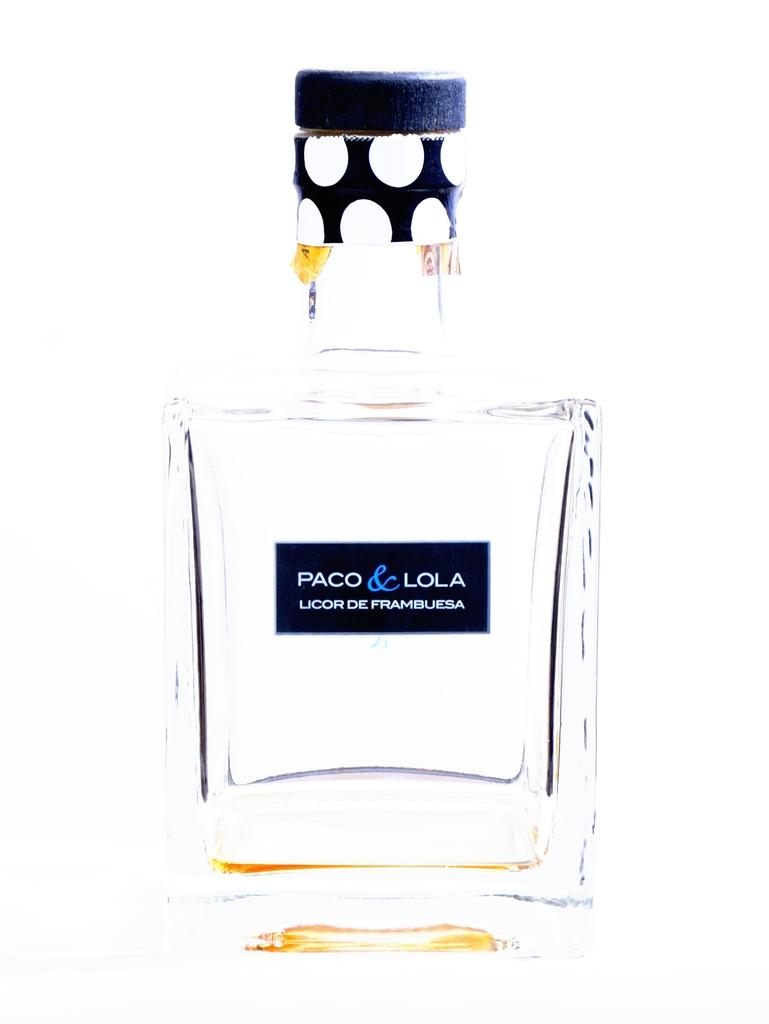<image>
Give a short and clear explanation of the subsequent image. Paco and lola licor de frambuesa perfume in picture 